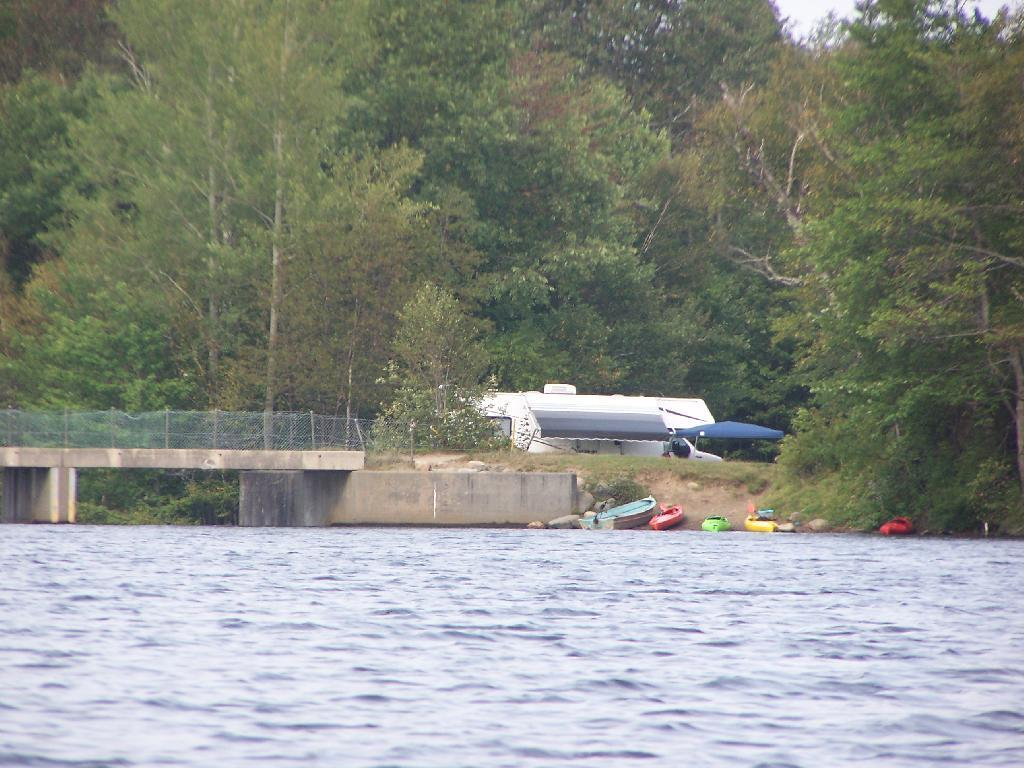What type of water feature can be seen in the image? There is a river in the image. How does the river appear to be crossed? There is a bridge over the river in the image. What feature can be seen on the bridge? The bridge has fencing. What type of vegetation is visible in the image? There are trees visible in the image. What mode of transportation can be seen in the image? There is a vehicle in the image. What type of watercraft is present in the image? There are boats in the image. How many bulbs are hanging from the trees in the image? There are no bulbs hanging from the trees in the image; only trees are visible. What type of pocket can be seen on the bridge in the image? There are no pockets present in the image, as it features a bridge over a river with trees and boats. 